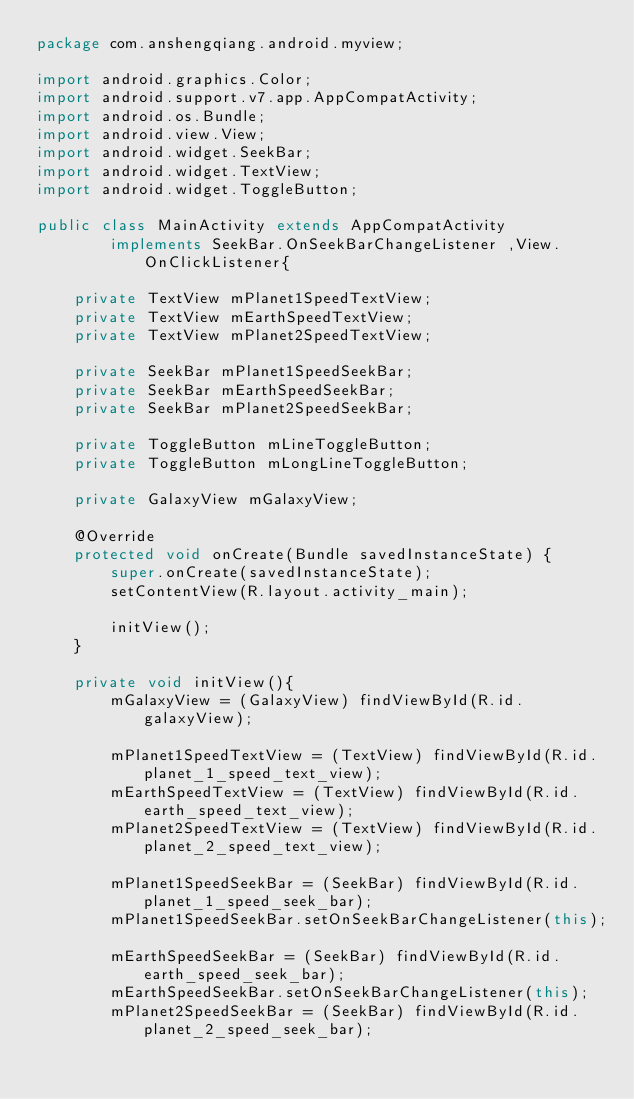Convert code to text. <code><loc_0><loc_0><loc_500><loc_500><_Java_>package com.anshengqiang.android.myview;

import android.graphics.Color;
import android.support.v7.app.AppCompatActivity;
import android.os.Bundle;
import android.view.View;
import android.widget.SeekBar;
import android.widget.TextView;
import android.widget.ToggleButton;

public class MainActivity extends AppCompatActivity
        implements SeekBar.OnSeekBarChangeListener ,View.OnClickListener{

    private TextView mPlanet1SpeedTextView;
    private TextView mEarthSpeedTextView;
    private TextView mPlanet2SpeedTextView;

    private SeekBar mPlanet1SpeedSeekBar;
    private SeekBar mEarthSpeedSeekBar;
    private SeekBar mPlanet2SpeedSeekBar;

    private ToggleButton mLineToggleButton;
    private ToggleButton mLongLineToggleButton;
    
    private GalaxyView mGalaxyView;

    @Override
    protected void onCreate(Bundle savedInstanceState) {
        super.onCreate(savedInstanceState);
        setContentView(R.layout.activity_main);

        initView();
    }

    private void initView(){
        mGalaxyView = (GalaxyView) findViewById(R.id.galaxyView);

        mPlanet1SpeedTextView = (TextView) findViewById(R.id.planet_1_speed_text_view);
        mEarthSpeedTextView = (TextView) findViewById(R.id.earth_speed_text_view);
        mPlanet2SpeedTextView = (TextView) findViewById(R.id.planet_2_speed_text_view);

        mPlanet1SpeedSeekBar = (SeekBar) findViewById(R.id.planet_1_speed_seek_bar);
        mPlanet1SpeedSeekBar.setOnSeekBarChangeListener(this);
        
        mEarthSpeedSeekBar = (SeekBar) findViewById(R.id.earth_speed_seek_bar);
        mEarthSpeedSeekBar.setOnSeekBarChangeListener(this);
        mPlanet2SpeedSeekBar = (SeekBar) findViewById(R.id.planet_2_speed_seek_bar);</code> 